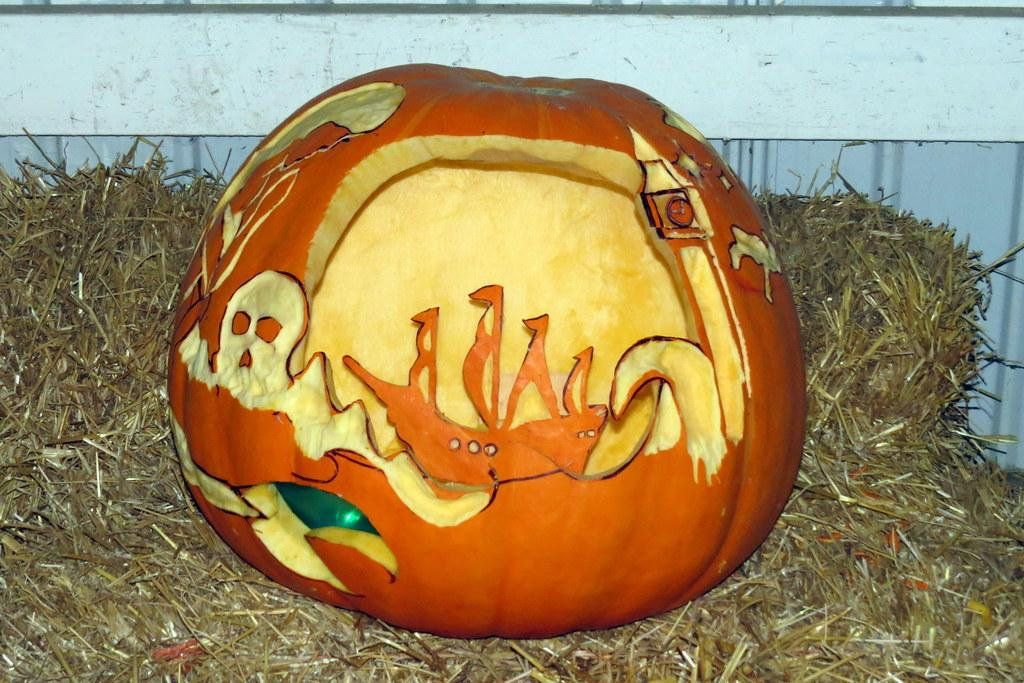Where was the image taken? The image is taken outdoors. What can be seen in the background of the image? There is a wall in the background of the image. What type of vegetation is present at the bottom of the image? Dry grass is present at the bottom of the image. What is the main subject in the middle of the image? There is a carved pumpkin in the middle of the image. On what surface is the carved pumpkin placed? The carved pumpkin is on the grass. What is the history of the army depicted in the image? There is no army present in the image; it features a carved pumpkin on dry grass. How much profit does the pumpkin generate in the image? The image does not depict any financial transactions or profits related to the pumpkin. 